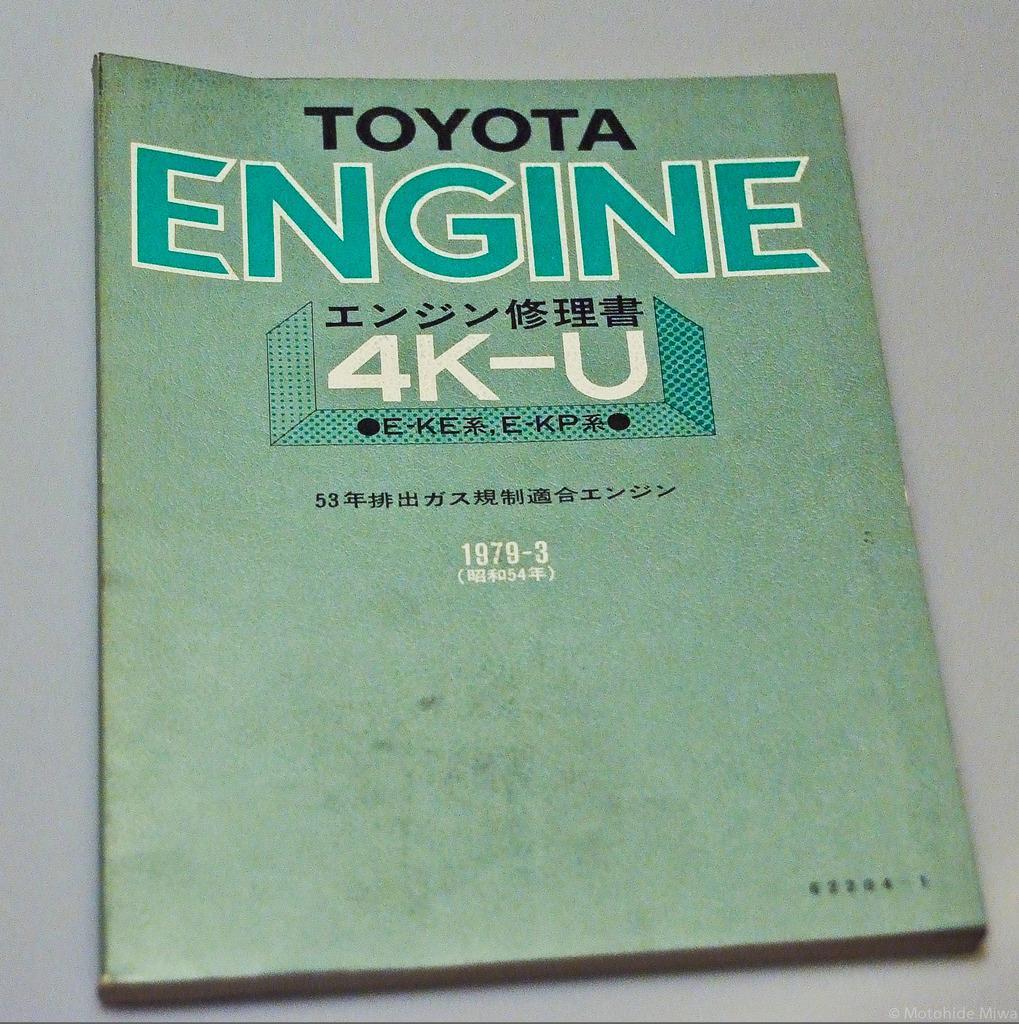Please provide a concise description of this image. In the center of the picture there is a book, on a white surface. On the book there is text. The book is in light green color. 